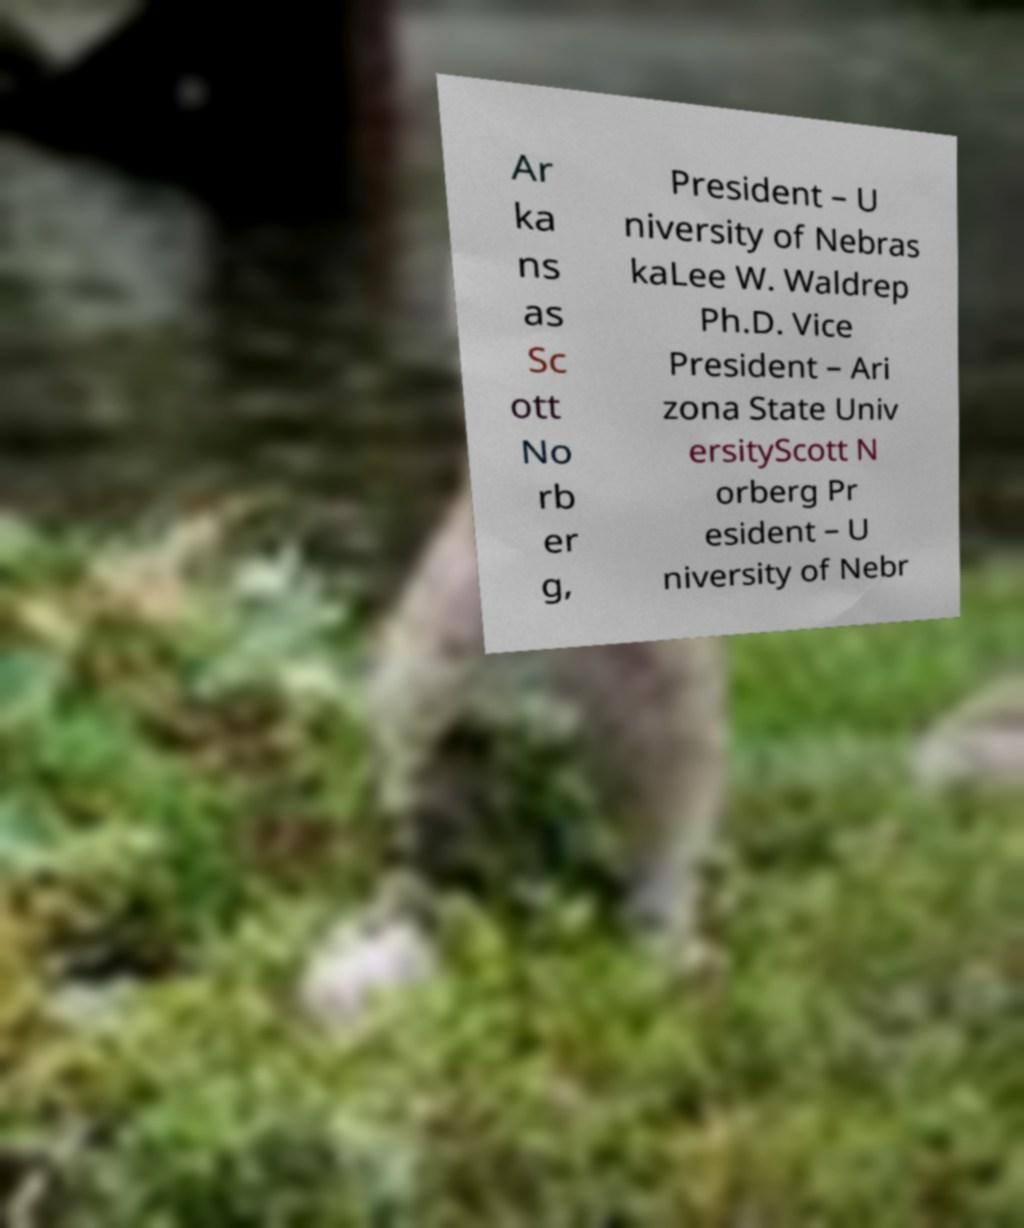Could you assist in decoding the text presented in this image and type it out clearly? Ar ka ns as Sc ott No rb er g, President – U niversity of Nebras kaLee W. Waldrep Ph.D. Vice President – Ari zona State Univ ersityScott N orberg Pr esident – U niversity of Nebr 